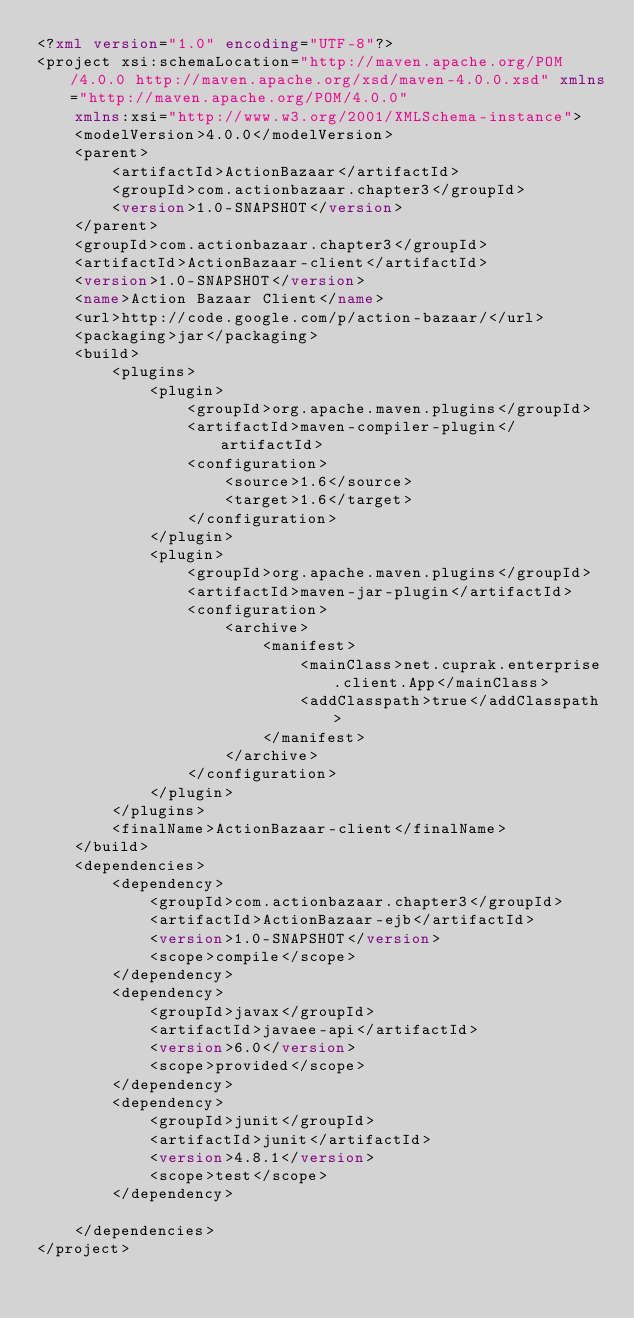<code> <loc_0><loc_0><loc_500><loc_500><_XML_><?xml version="1.0" encoding="UTF-8"?>
<project xsi:schemaLocation="http://maven.apache.org/POM/4.0.0 http://maven.apache.org/xsd/maven-4.0.0.xsd" xmlns="http://maven.apache.org/POM/4.0.0"
    xmlns:xsi="http://www.w3.org/2001/XMLSchema-instance">
    <modelVersion>4.0.0</modelVersion>
    <parent>
        <artifactId>ActionBazaar</artifactId>
        <groupId>com.actionbazaar.chapter3</groupId>
        <version>1.0-SNAPSHOT</version>
    </parent>
    <groupId>com.actionbazaar.chapter3</groupId>
    <artifactId>ActionBazaar-client</artifactId>
    <version>1.0-SNAPSHOT</version>
    <name>Action Bazaar Client</name>
    <url>http://code.google.com/p/action-bazaar/</url>
    <packaging>jar</packaging>
    <build>
        <plugins>
            <plugin>
                <groupId>org.apache.maven.plugins</groupId>
                <artifactId>maven-compiler-plugin</artifactId>
                <configuration>
                    <source>1.6</source>
                    <target>1.6</target>
                </configuration>
            </plugin>
            <plugin>
                <groupId>org.apache.maven.plugins</groupId>
                <artifactId>maven-jar-plugin</artifactId>
                <configuration>
                    <archive>
                        <manifest>
                            <mainClass>net.cuprak.enterprise.client.App</mainClass>
                            <addClasspath>true</addClasspath>
                        </manifest>
                    </archive>
                </configuration>
            </plugin>
        </plugins>
        <finalName>ActionBazaar-client</finalName>
    </build>
    <dependencies>
        <dependency>
            <groupId>com.actionbazaar.chapter3</groupId>
            <artifactId>ActionBazaar-ejb</artifactId>
            <version>1.0-SNAPSHOT</version>
            <scope>compile</scope>
        </dependency>
        <dependency>
            <groupId>javax</groupId>
            <artifactId>javaee-api</artifactId>
            <version>6.0</version>
            <scope>provided</scope>
        </dependency>
        <dependency>
            <groupId>junit</groupId>
            <artifactId>junit</artifactId>
            <version>4.8.1</version>
            <scope>test</scope>
        </dependency>

    </dependencies>
</project>
</code> 